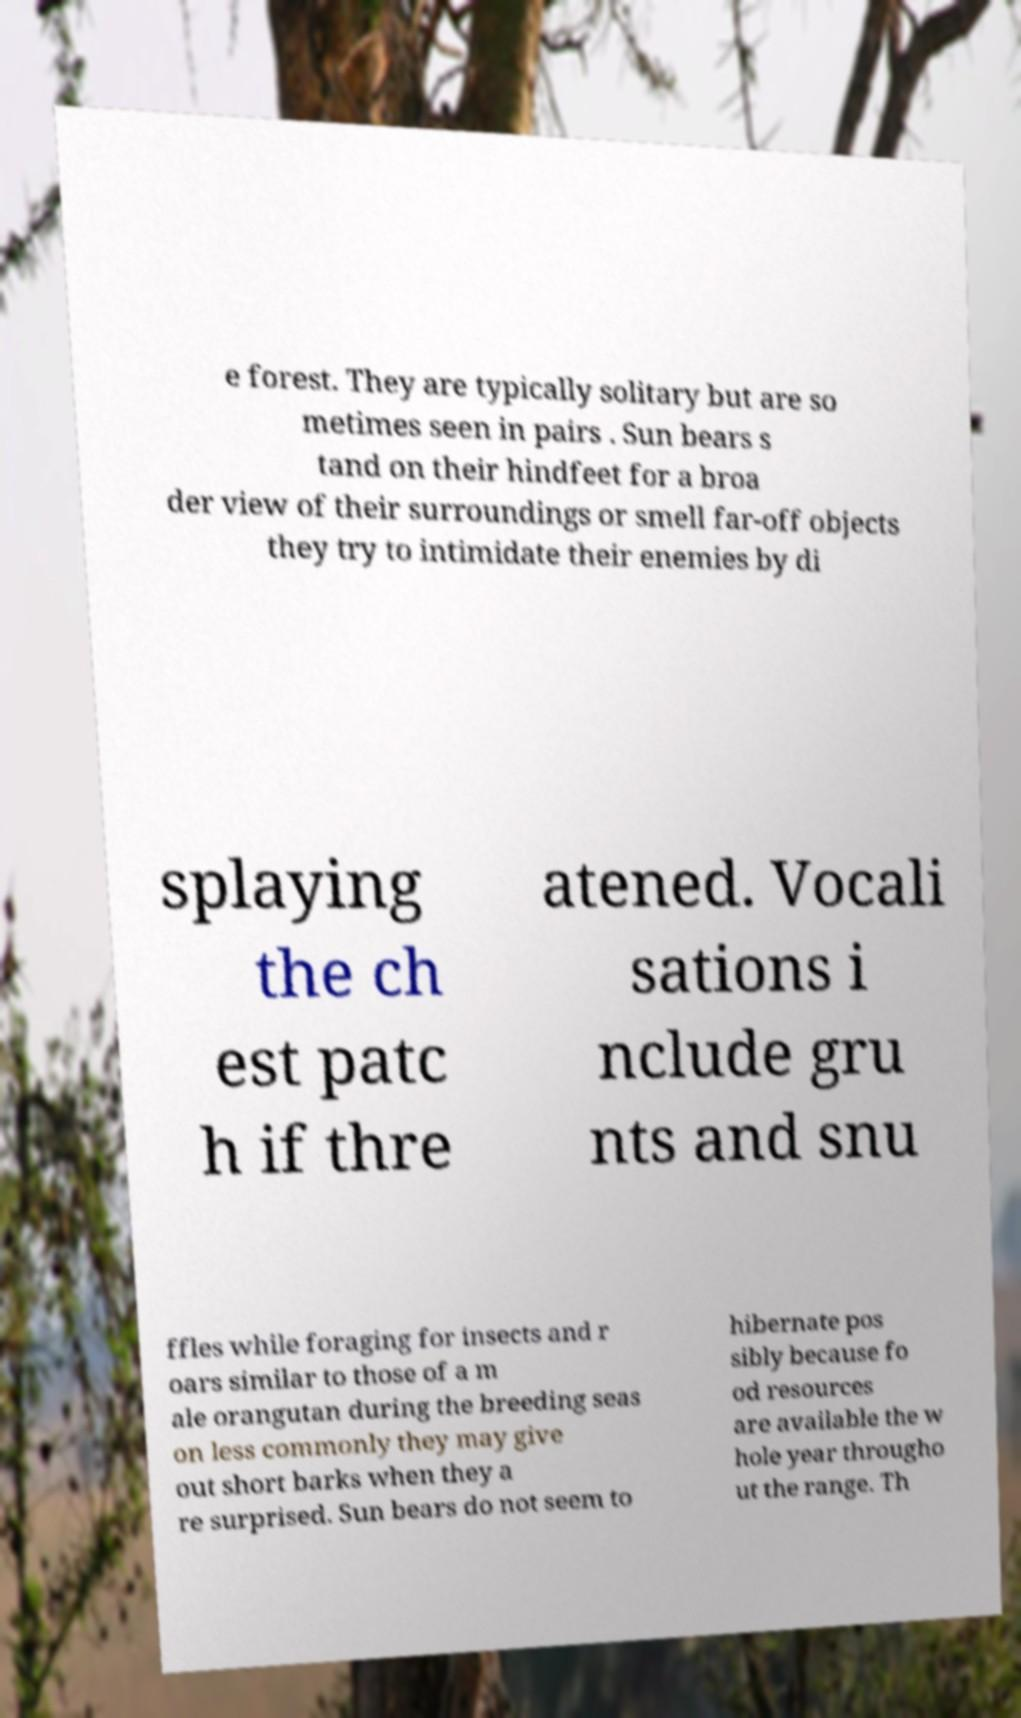There's text embedded in this image that I need extracted. Can you transcribe it verbatim? e forest. They are typically solitary but are so metimes seen in pairs . Sun bears s tand on their hindfeet for a broa der view of their surroundings or smell far-off objects they try to intimidate their enemies by di splaying the ch est patc h if thre atened. Vocali sations i nclude gru nts and snu ffles while foraging for insects and r oars similar to those of a m ale orangutan during the breeding seas on less commonly they may give out short barks when they a re surprised. Sun bears do not seem to hibernate pos sibly because fo od resources are available the w hole year througho ut the range. Th 